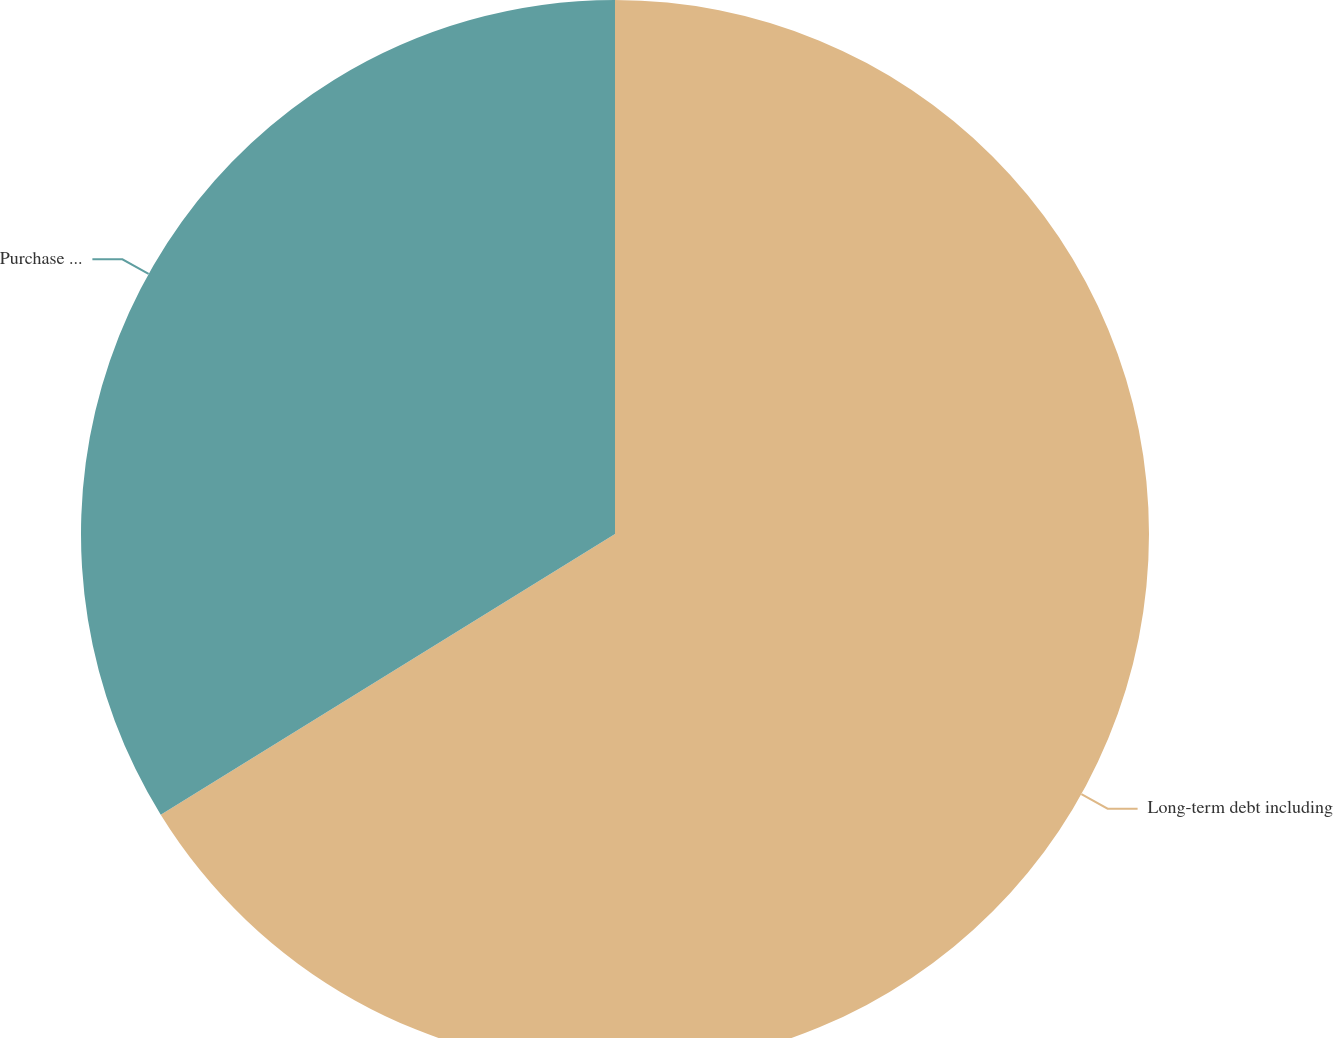Convert chart. <chart><loc_0><loc_0><loc_500><loc_500><pie_chart><fcel>Long-term debt including<fcel>Purchase obligations (1)<nl><fcel>66.19%<fcel>33.81%<nl></chart> 